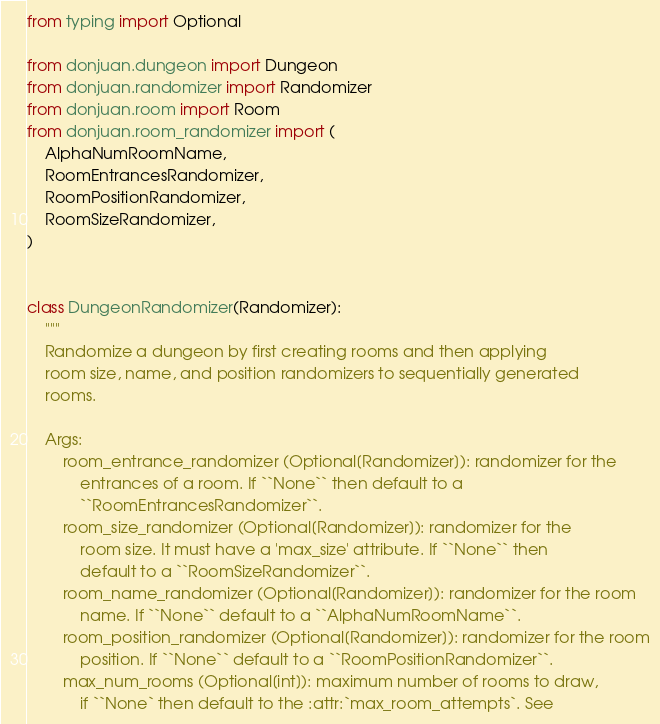<code> <loc_0><loc_0><loc_500><loc_500><_Python_>from typing import Optional

from donjuan.dungeon import Dungeon
from donjuan.randomizer import Randomizer
from donjuan.room import Room
from donjuan.room_randomizer import (
    AlphaNumRoomName,
    RoomEntrancesRandomizer,
    RoomPositionRandomizer,
    RoomSizeRandomizer,
)


class DungeonRandomizer(Randomizer):
    """
    Randomize a dungeon by first creating rooms and then applying
    room size, name, and position randomizers to sequentially generated
    rooms.

    Args:
        room_entrance_randomizer (Optional[Randomizer]): randomizer for the
            entrances of a room. If ``None`` then default to a
            ``RoomEntrancesRandomizer``.
        room_size_randomizer (Optional[Randomizer]): randomizer for the
            room size. It must have a 'max_size' attribute. If ``None`` then
            default to a ``RoomSizeRandomizer``.
        room_name_randomizer (Optional[Randomizer]): randomizer for the room
            name. If ``None`` default to a ``AlphaNumRoomName``.
        room_position_randomizer (Optional[Randomizer]): randomizer for the room
            position. If ``None`` default to a ``RoomPositionRandomizer``.
        max_num_rooms (Optional[int]): maximum number of rooms to draw,
            if ``None` then default to the :attr:`max_room_attempts`. See</code> 